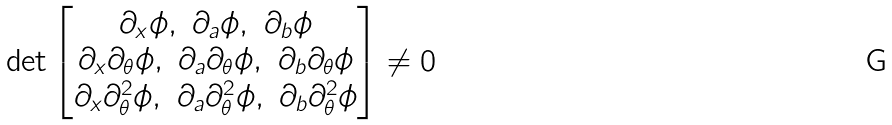Convert formula to latex. <formula><loc_0><loc_0><loc_500><loc_500>\det \begin{bmatrix} \partial _ { x } \phi , \ \partial _ { a } \phi , \ \partial _ { b } \phi \\ \partial _ { x } \partial _ { \theta } \phi , \ \partial _ { a } \partial _ { \theta } \phi , \ \partial _ { b } \partial _ { \theta } \phi \\ \partial _ { x } \partial ^ { 2 } _ { \theta } \phi , \ \partial _ { a } \partial ^ { 2 } _ { \theta } \phi , \ \partial _ { b } \partial ^ { 2 } _ { \theta } \phi \end{bmatrix} \neq 0</formula> 